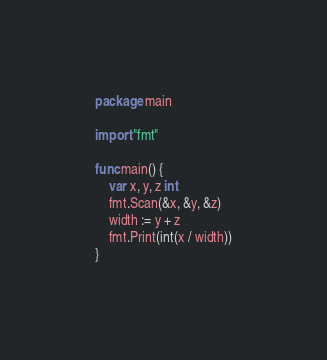Convert code to text. <code><loc_0><loc_0><loc_500><loc_500><_Go_>package main

import "fmt"

func main() {
	var x, y, z int
	fmt.Scan(&x, &y, &z)
	width := y + z
	fmt.Print(int(x / width))
}
</code> 